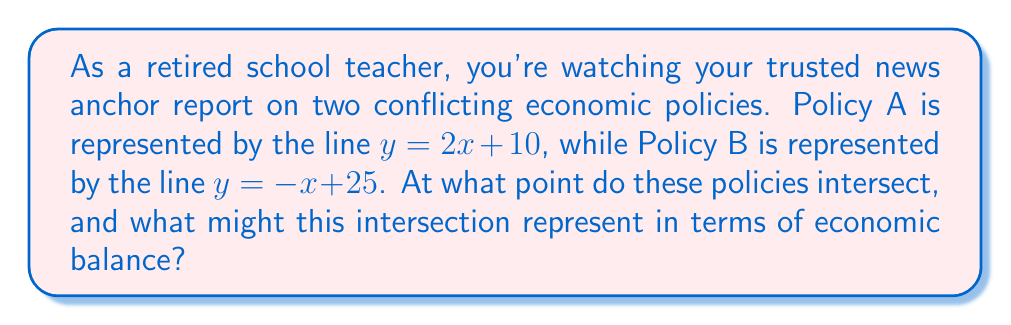Provide a solution to this math problem. To find the intersection point of these two lines, we need to solve the system of equations:

$$\begin{cases}
y = 2x + 10 \quad \text{(Policy A)} \\
y = -x + 25 \quad \text{(Policy B)}
\end{cases}$$

Since both equations are equal to $y$, we can set them equal to each other:

$$2x + 10 = -x + 25$$

Now, let's solve for $x$:

$$\begin{align}
2x + 10 &= -x + 25 \\
3x &= 15 \\
x &= 5
\end{align}$$

Now that we know $x = 5$, we can substitute this value into either of the original equations to find $y$. Let's use Policy A's equation:

$$\begin{align}
y &= 2x + 10 \\
y &= 2(5) + 10 \\
y &= 20
\end{align}$$

Therefore, the intersection point is $(5, 20)$.

[asy]
import graph;
size(200);
xaxis("x", -1, 10, arrow=Arrow);
yaxis("y", -1, 30, arrow=Arrow);
draw((0,10)--(7,24), blue, Arrows);
draw((0,25)--(10,15), red, Arrows);
dot((5,20), purple);
label("(5, 20)", (5,20), NE);
label("Policy A", (7,24), NE, blue);
label("Policy B", (10,15), SE, red);
[/asy]

In economic terms, this intersection point could represent a balance between the two conflicting policies. At this point, both policies yield the same outcome, which might indicate a potential compromise or an optimal point where the benefits of both policies are maximized.
Answer: The intersection point of the two lines representing the conflicting economic policies is $(5, 20)$. 